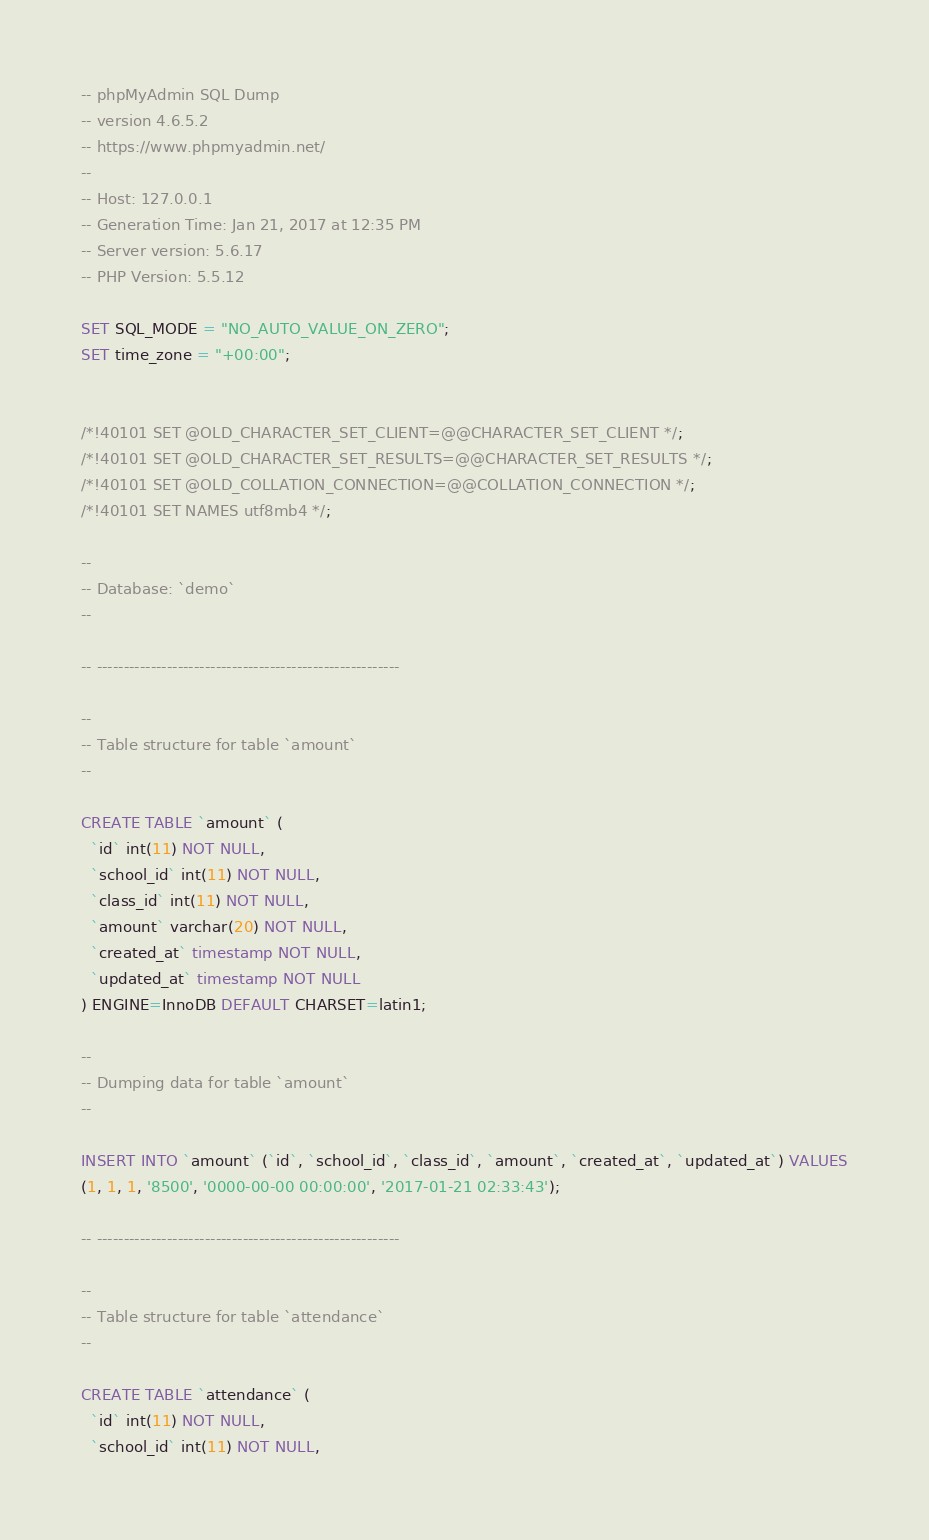Convert code to text. <code><loc_0><loc_0><loc_500><loc_500><_SQL_>-- phpMyAdmin SQL Dump
-- version 4.6.5.2
-- https://www.phpmyadmin.net/
--
-- Host: 127.0.0.1
-- Generation Time: Jan 21, 2017 at 12:35 PM
-- Server version: 5.6.17
-- PHP Version: 5.5.12

SET SQL_MODE = "NO_AUTO_VALUE_ON_ZERO";
SET time_zone = "+00:00";


/*!40101 SET @OLD_CHARACTER_SET_CLIENT=@@CHARACTER_SET_CLIENT */;
/*!40101 SET @OLD_CHARACTER_SET_RESULTS=@@CHARACTER_SET_RESULTS */;
/*!40101 SET @OLD_COLLATION_CONNECTION=@@COLLATION_CONNECTION */;
/*!40101 SET NAMES utf8mb4 */;

--
-- Database: `demo`
--

-- --------------------------------------------------------

--
-- Table structure for table `amount`
--

CREATE TABLE `amount` (
  `id` int(11) NOT NULL,
  `school_id` int(11) NOT NULL,
  `class_id` int(11) NOT NULL,
  `amount` varchar(20) NOT NULL,
  `created_at` timestamp NOT NULL,
  `updated_at` timestamp NOT NULL
) ENGINE=InnoDB DEFAULT CHARSET=latin1;

--
-- Dumping data for table `amount`
--

INSERT INTO `amount` (`id`, `school_id`, `class_id`, `amount`, `created_at`, `updated_at`) VALUES
(1, 1, 1, '8500', '0000-00-00 00:00:00', '2017-01-21 02:33:43');

-- --------------------------------------------------------

--
-- Table structure for table `attendance`
--

CREATE TABLE `attendance` (
  `id` int(11) NOT NULL,
  `school_id` int(11) NOT NULL,</code> 